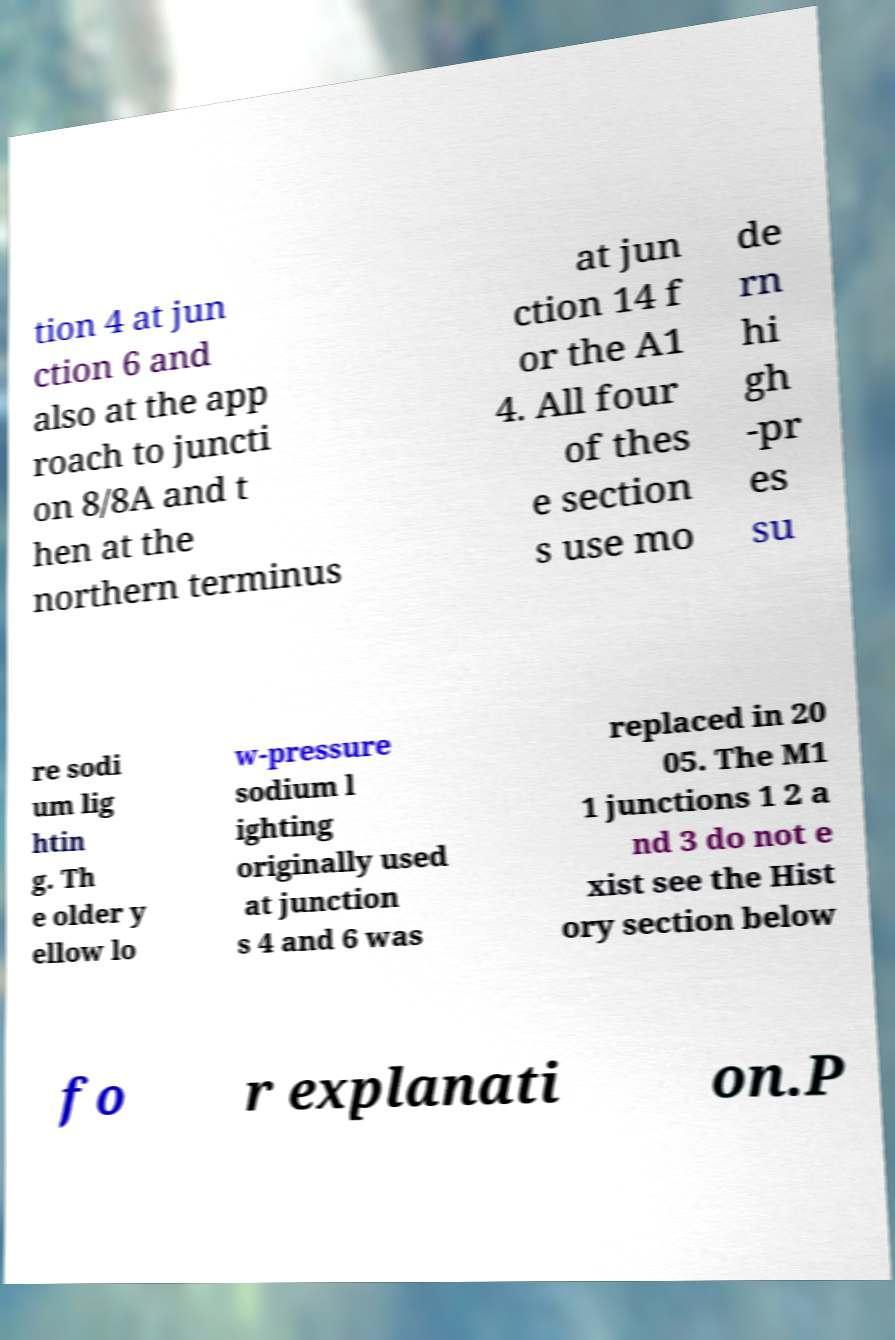Could you extract and type out the text from this image? tion 4 at jun ction 6 and also at the app roach to juncti on 8/8A and t hen at the northern terminus at jun ction 14 f or the A1 4. All four of thes e section s use mo de rn hi gh -pr es su re sodi um lig htin g. Th e older y ellow lo w-pressure sodium l ighting originally used at junction s 4 and 6 was replaced in 20 05. The M1 1 junctions 1 2 a nd 3 do not e xist see the Hist ory section below fo r explanati on.P 